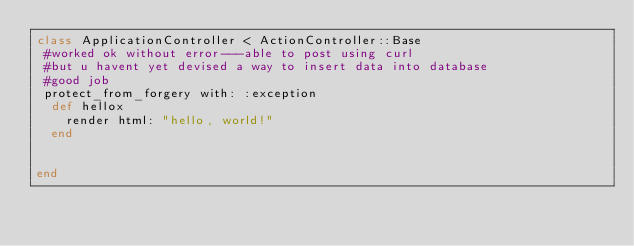<code> <loc_0><loc_0><loc_500><loc_500><_Ruby_>class ApplicationController < ActionController::Base
 #worked ok without error---able to post using curl 
 #but u havent yet devised a way to insert data into database
 #good job
 protect_from_forgery with: :exception
  def hellox
    render html: "hello, world!"
  end


end
</code> 